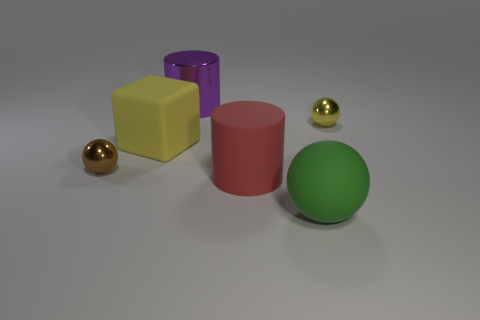What number of other things are there of the same shape as the large red matte thing?
Offer a very short reply. 1. How many gray objects are either shiny cylinders or matte blocks?
Make the answer very short. 0. Do the large sphere and the large cylinder that is in front of the large metal cylinder have the same material?
Your response must be concise. Yes. Is the number of big green rubber objects on the left side of the red cylinder the same as the number of small yellow objects behind the tiny yellow shiny ball?
Give a very brief answer. Yes. Does the yellow sphere have the same size as the rubber object left of the purple thing?
Ensure brevity in your answer.  No. Is the number of big rubber objects that are behind the red object greater than the number of shiny balls?
Provide a short and direct response. No. How many purple cylinders have the same size as the brown ball?
Provide a succinct answer. 0. Do the yellow block that is behind the big red thing and the metallic sphere to the left of the red matte thing have the same size?
Give a very brief answer. No. Are there more shiny objects that are behind the big yellow cube than brown metal balls that are to the right of the green rubber thing?
Your response must be concise. Yes. What number of yellow things have the same shape as the purple thing?
Your response must be concise. 0. 